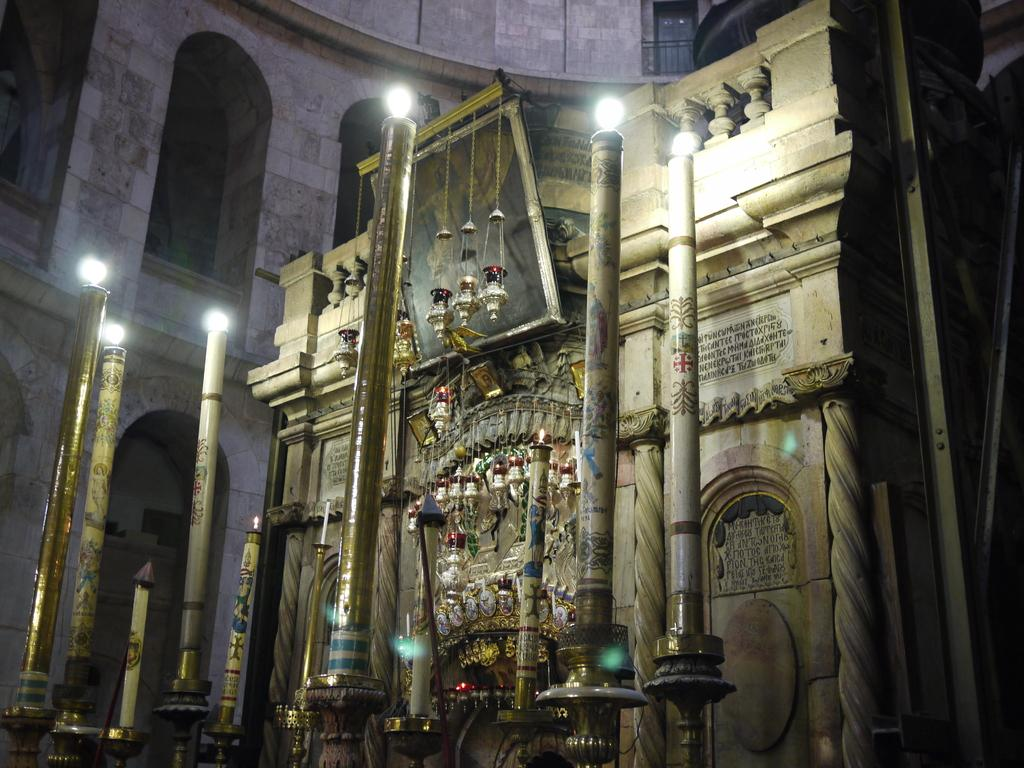What can be seen in the image that might hold a photograph? There is a photo frame in the image. What is written or displayed on the wall in the image? There is text on the wall in the image. What type of vertical structures are present in the image? There are poles in the image. What can be seen in the image that provides illumination? There are lights in the image. What type of objects are present in the image that serve a decorative purpose? There are decorative objects in the image. What other objects can be seen in the image besides those mentioned? There are other objects in the image. What type of trouble is depicted in the image? There is no depiction of trouble in the image; it contains a photo frame, text on the wall, poles, lights, decorative objects, and other objects. What fictional characters are present in the image? There are no fictional characters present in the image; it contains a photo frame, text on the wall, poles, lights, decorative objects, and other objects. 